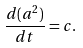Convert formula to latex. <formula><loc_0><loc_0><loc_500><loc_500>\frac { d ( a ^ { 2 } ) } { d t } = c .</formula> 